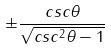Convert formula to latex. <formula><loc_0><loc_0><loc_500><loc_500>\pm \frac { c s c \theta } { \sqrt { c s c ^ { 2 } \theta - 1 } }</formula> 